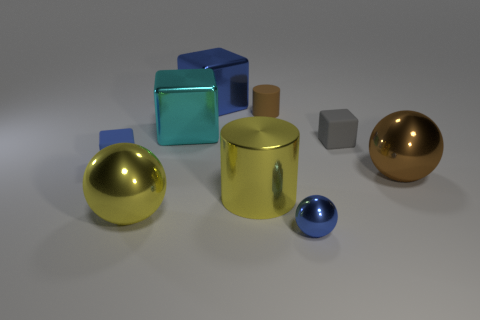The metal sphere that is behind the sphere left of the large blue cube is what color? brown 